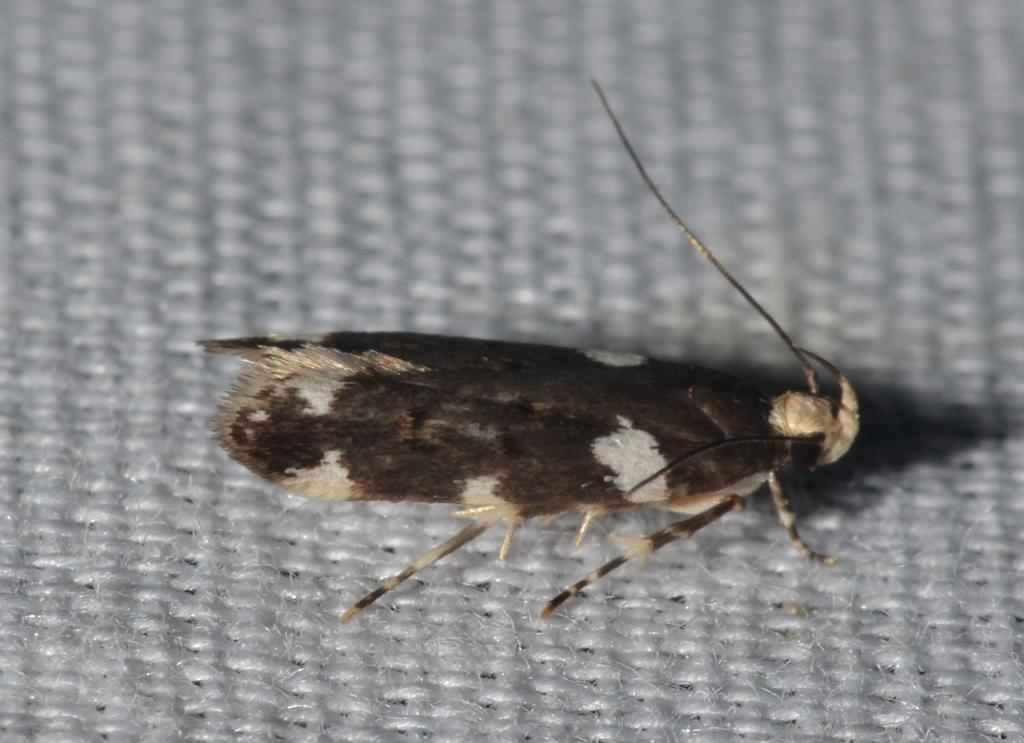What is the main subject in the center of the image? There is an insect in the center of the image. What surface is the insect located on? The insect is on a carpet. What type of knowledge does the insect possess in the image? There is no indication in the image that the insect possesses any knowledge. 